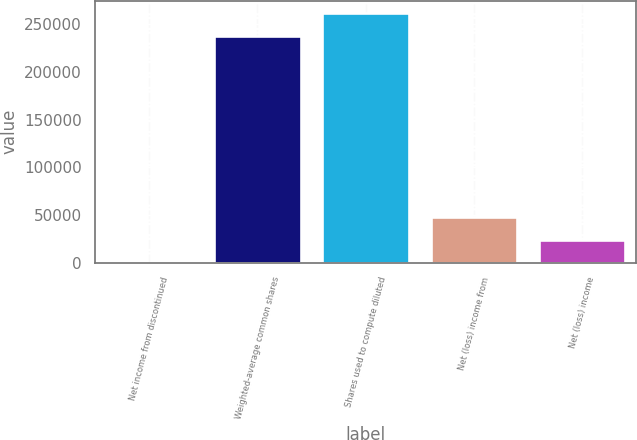<chart> <loc_0><loc_0><loc_500><loc_500><bar_chart><fcel>Net income from discontinued<fcel>Weighted-average common shares<fcel>Shares used to compute diluted<fcel>Net (loss) income from<fcel>Net (loss) income<nl><fcel>0.02<fcel>237707<fcel>261478<fcel>47541.4<fcel>23770.7<nl></chart> 